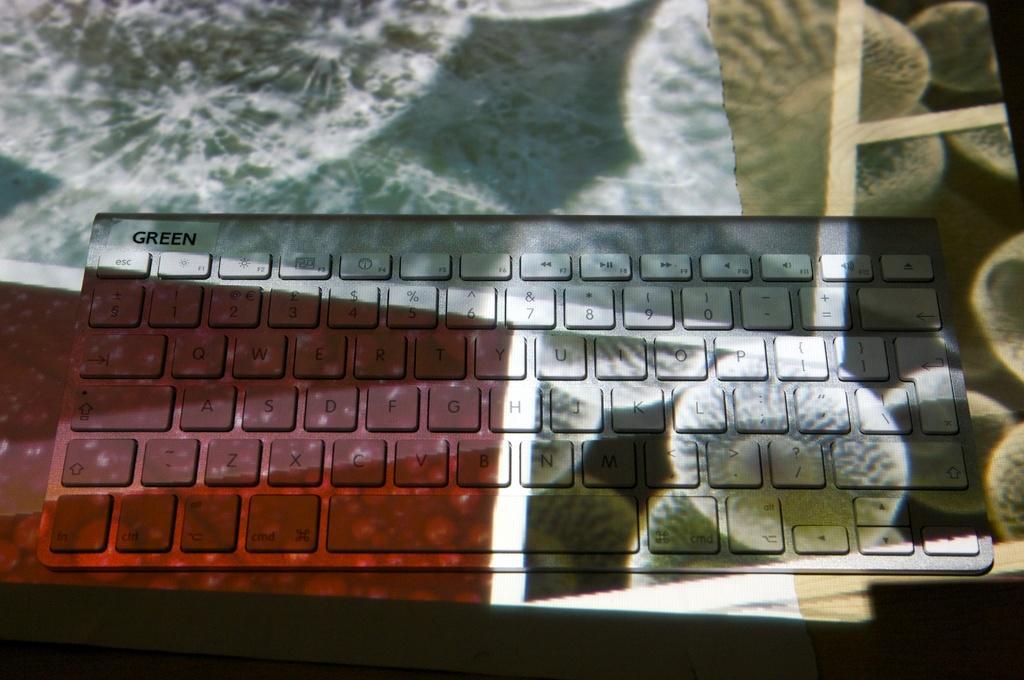Could you give a brief overview of what you see in this image? In the center of the image, we can see a keyboard on the table and there are some decor papers. 